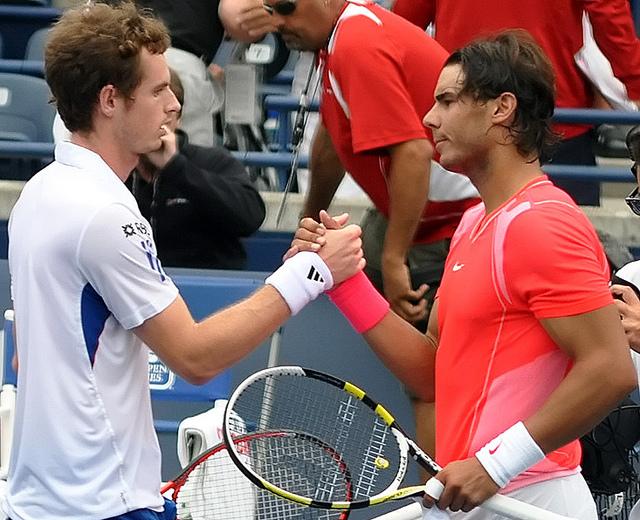What are they doing?
Short answer required. Shaking hands. What color of the shirt is the guy on the right wearing?
Answer briefly. Red. Is the match over?
Short answer required. Yes. 